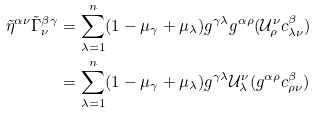<formula> <loc_0><loc_0><loc_500><loc_500>\tilde { \eta } ^ { \alpha \nu } \tilde { \Gamma } _ { \nu } ^ { \beta \gamma } & = \sum _ { \lambda = 1 } ^ { n } ( 1 - \mu _ { \gamma } + \mu _ { \lambda } ) g ^ { \gamma \lambda } g ^ { \alpha \rho } ( \mathcal { U } ^ { \nu } _ { \rho } c ^ { \beta } _ { \lambda \nu } ) \\ & = \sum _ { \lambda = 1 } ^ { n } ( 1 - \mu _ { \gamma } + \mu _ { \lambda } ) g ^ { \gamma \lambda } \mathcal { U } ^ { \nu } _ { \lambda } ( g ^ { \alpha \rho } c ^ { \beta } _ { \rho \nu } )</formula> 